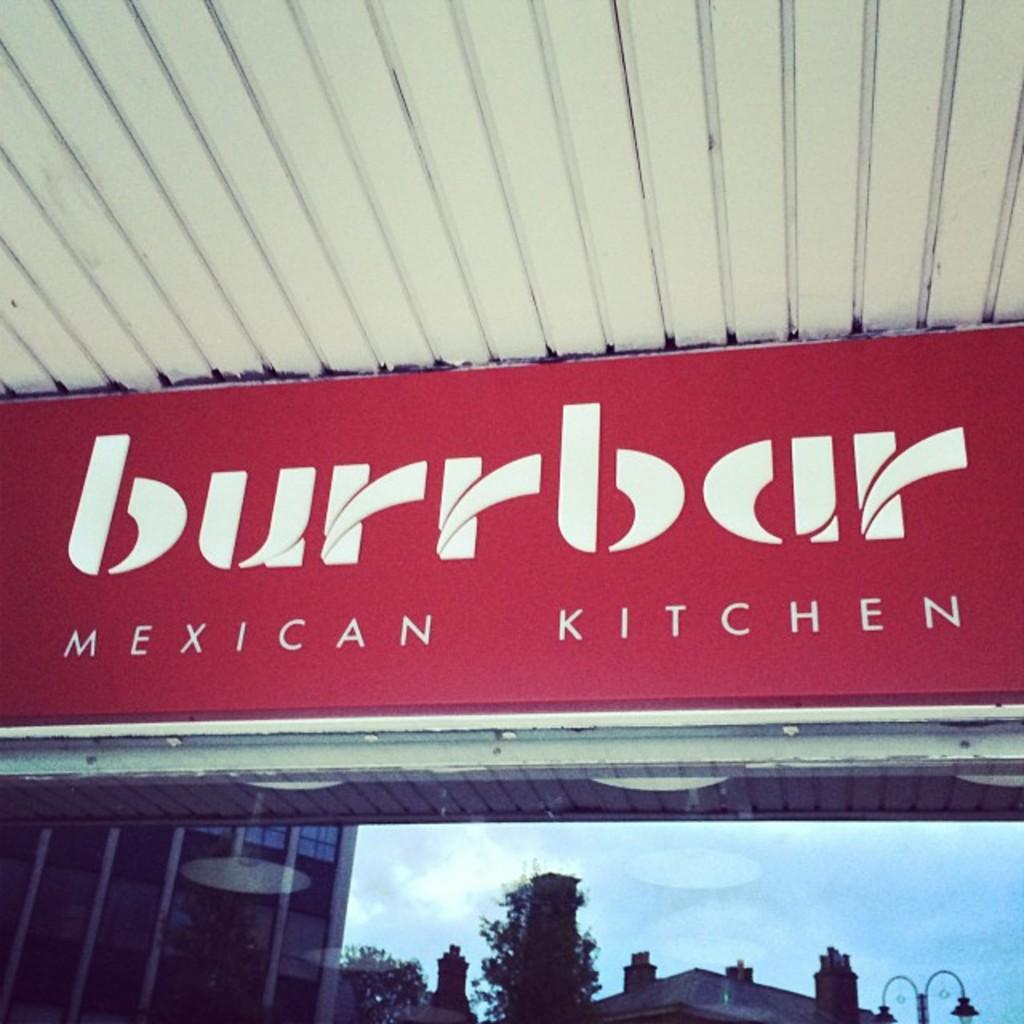<image>
Render a clear and concise summary of the photo. a red outside sign for Burrbar Mexican Kitchen 